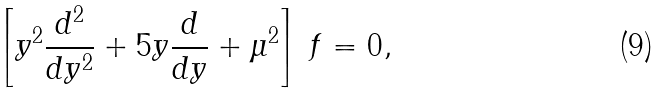Convert formula to latex. <formula><loc_0><loc_0><loc_500><loc_500>\left [ y ^ { 2 } \frac { d ^ { 2 } } { d y ^ { 2 } } + 5 y \frac { d } { d y } + \mu ^ { 2 } \right ] \, f = 0 ,</formula> 